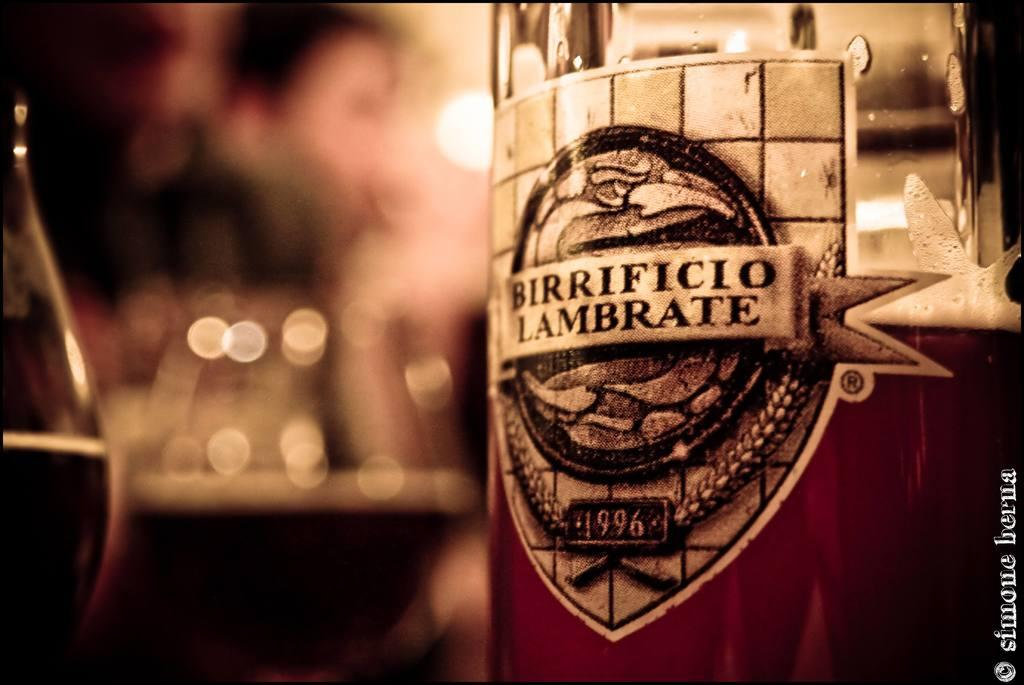<image>
Give a short and clear explanation of the subsequent image. Bottle of Birrificio Lambrate from 1996 next to glasses. 